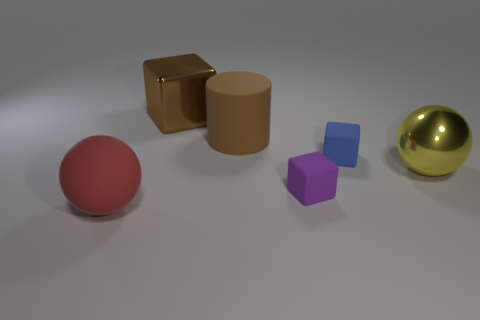There is a blue matte thing that is the same shape as the purple matte thing; what is its size?
Make the answer very short. Small. What is the size of the block that is the same color as the big cylinder?
Ensure brevity in your answer.  Large. Are there any metallic objects of the same size as the shiny block?
Keep it short and to the point. Yes. Do the brown cylinder and the big sphere on the right side of the tiny purple block have the same material?
Provide a short and direct response. No. Is the number of blocks greater than the number of green objects?
Provide a succinct answer. Yes. What number of cubes are rubber objects or yellow things?
Give a very brief answer. 2. The big metallic ball has what color?
Your answer should be compact. Yellow. Is the size of the metal thing on the left side of the big rubber cylinder the same as the block right of the purple matte thing?
Your answer should be compact. No. Are there fewer yellow balls than big cyan matte objects?
Keep it short and to the point. No. What number of brown cylinders are behind the red thing?
Keep it short and to the point. 1. 